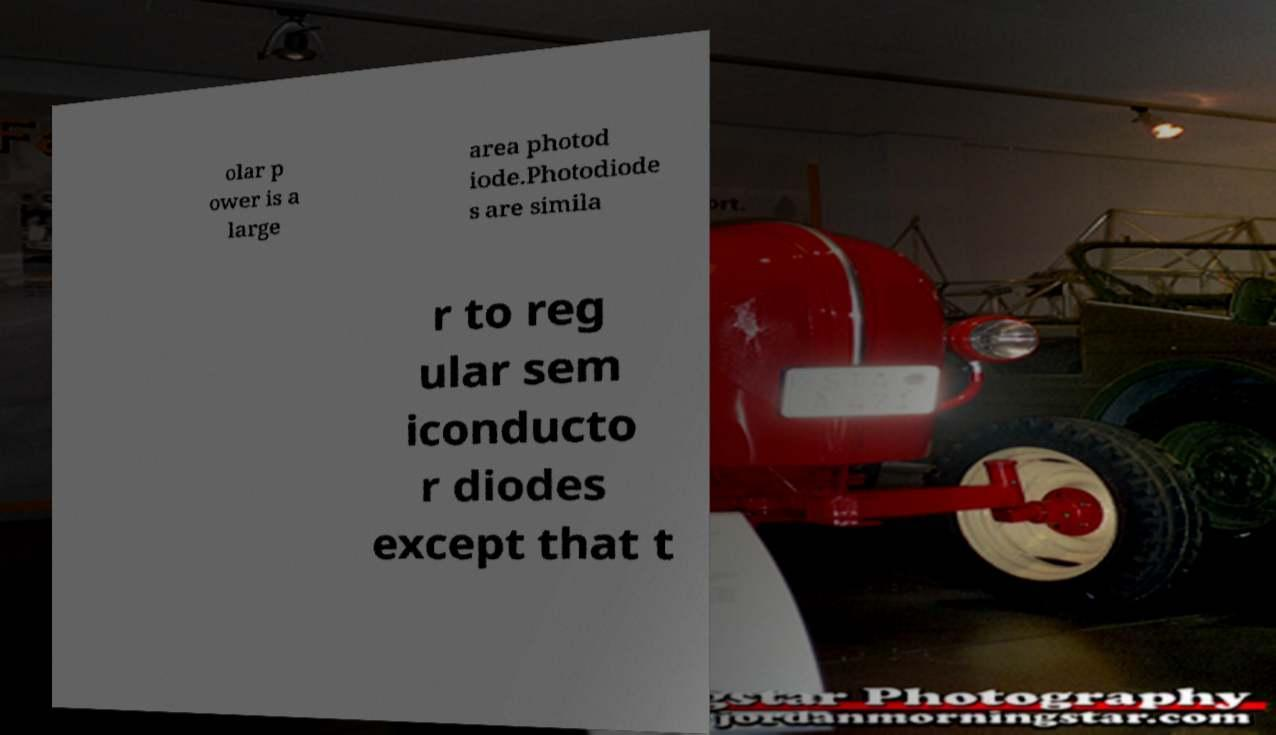I need the written content from this picture converted into text. Can you do that? olar p ower is a large area photod iode.Photodiode s are simila r to reg ular sem iconducto r diodes except that t 